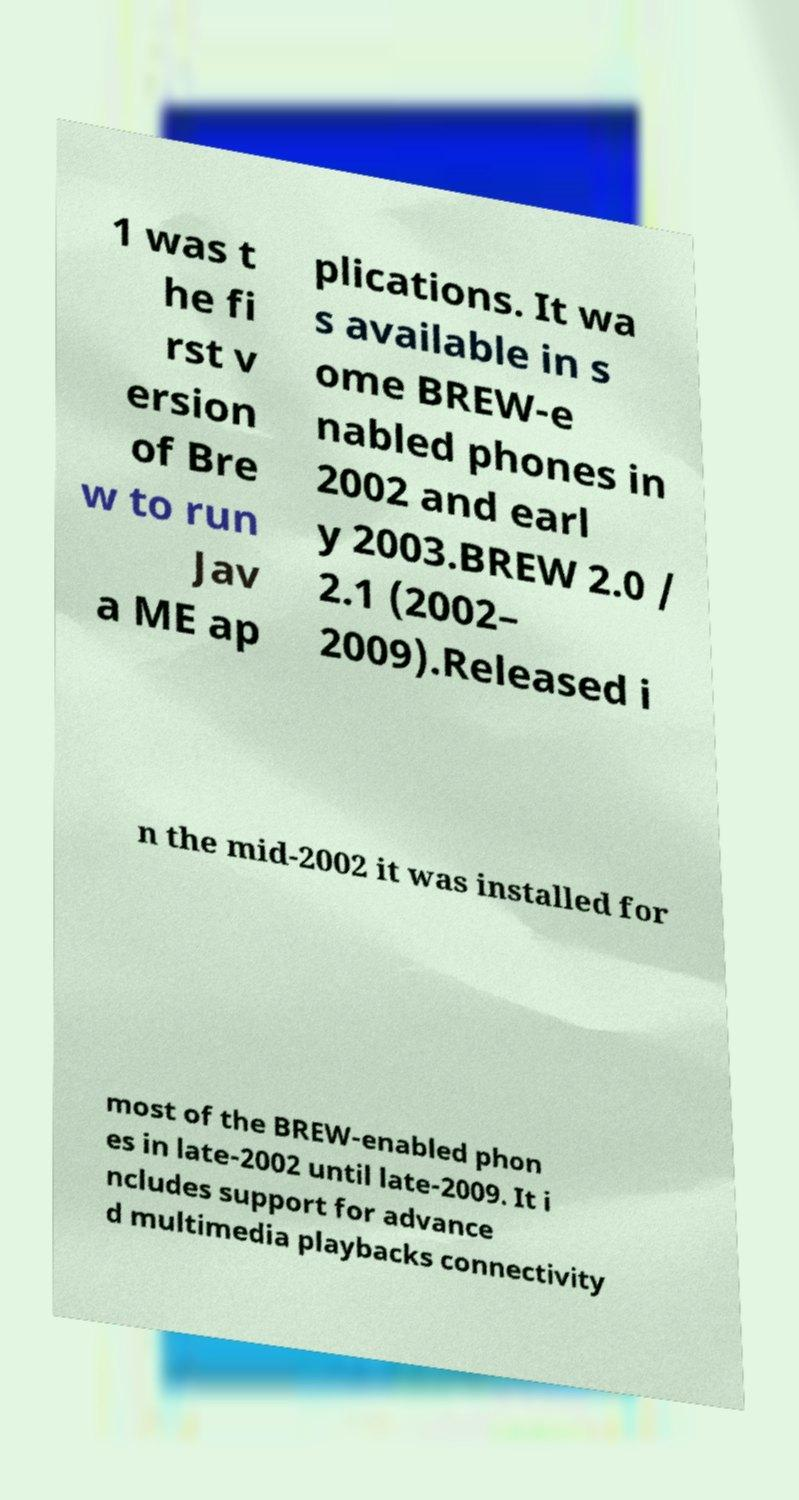Could you assist in decoding the text presented in this image and type it out clearly? 1 was t he fi rst v ersion of Bre w to run Jav a ME ap plications. It wa s available in s ome BREW-e nabled phones in 2002 and earl y 2003.BREW 2.0 / 2.1 (2002– 2009).Released i n the mid-2002 it was installed for most of the BREW-enabled phon es in late-2002 until late-2009. It i ncludes support for advance d multimedia playbacks connectivity 